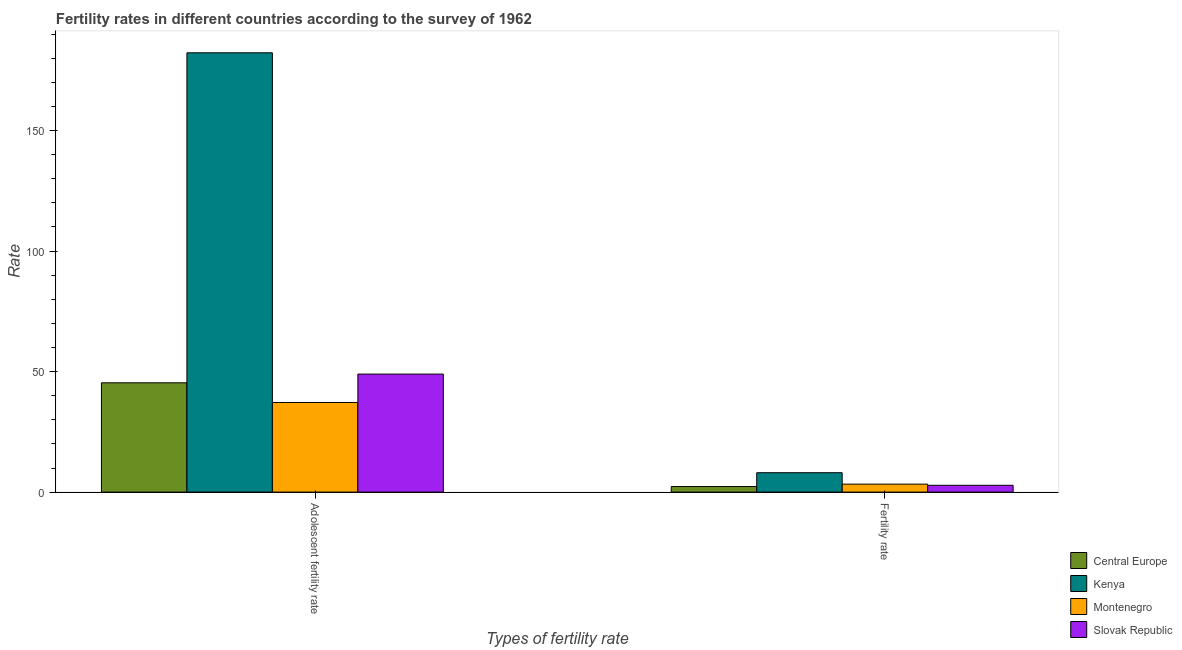Are the number of bars per tick equal to the number of legend labels?
Provide a succinct answer. Yes. How many bars are there on the 2nd tick from the left?
Provide a succinct answer. 4. How many bars are there on the 1st tick from the right?
Your answer should be very brief. 4. What is the label of the 2nd group of bars from the left?
Give a very brief answer. Fertility rate. What is the fertility rate in Slovak Republic?
Keep it short and to the point. 2.83. Across all countries, what is the maximum adolescent fertility rate?
Provide a succinct answer. 182.27. Across all countries, what is the minimum adolescent fertility rate?
Keep it short and to the point. 37.17. In which country was the adolescent fertility rate maximum?
Ensure brevity in your answer.  Kenya. In which country was the fertility rate minimum?
Your answer should be compact. Central Europe. What is the total fertility rate in the graph?
Provide a succinct answer. 16.49. What is the difference between the fertility rate in Kenya and that in Slovak Republic?
Your answer should be compact. 5.21. What is the difference between the adolescent fertility rate in Central Europe and the fertility rate in Montenegro?
Provide a succinct answer. 42.04. What is the average fertility rate per country?
Give a very brief answer. 4.12. What is the difference between the adolescent fertility rate and fertility rate in Central Europe?
Offer a terse response. 43.03. What is the ratio of the fertility rate in Central Europe to that in Slovak Republic?
Ensure brevity in your answer.  0.82. Is the fertility rate in Slovak Republic less than that in Montenegro?
Your answer should be very brief. Yes. What does the 2nd bar from the left in Adolescent fertility rate represents?
Provide a succinct answer. Kenya. What does the 2nd bar from the right in Adolescent fertility rate represents?
Offer a terse response. Montenegro. How many countries are there in the graph?
Offer a very short reply. 4. Does the graph contain any zero values?
Keep it short and to the point. No. How many legend labels are there?
Your response must be concise. 4. How are the legend labels stacked?
Provide a succinct answer. Vertical. What is the title of the graph?
Your answer should be compact. Fertility rates in different countries according to the survey of 1962. What is the label or title of the X-axis?
Give a very brief answer. Types of fertility rate. What is the label or title of the Y-axis?
Provide a succinct answer. Rate. What is the Rate in Central Europe in Adolescent fertility rate?
Offer a terse response. 45.35. What is the Rate of Kenya in Adolescent fertility rate?
Make the answer very short. 182.27. What is the Rate in Montenegro in Adolescent fertility rate?
Offer a very short reply. 37.17. What is the Rate in Slovak Republic in Adolescent fertility rate?
Give a very brief answer. 48.96. What is the Rate of Central Europe in Fertility rate?
Give a very brief answer. 2.31. What is the Rate of Kenya in Fertility rate?
Give a very brief answer. 8.04. What is the Rate of Montenegro in Fertility rate?
Your response must be concise. 3.31. What is the Rate of Slovak Republic in Fertility rate?
Provide a succinct answer. 2.83. Across all Types of fertility rate, what is the maximum Rate in Central Europe?
Make the answer very short. 45.35. Across all Types of fertility rate, what is the maximum Rate of Kenya?
Make the answer very short. 182.27. Across all Types of fertility rate, what is the maximum Rate in Montenegro?
Offer a very short reply. 37.17. Across all Types of fertility rate, what is the maximum Rate of Slovak Republic?
Give a very brief answer. 48.96. Across all Types of fertility rate, what is the minimum Rate of Central Europe?
Your response must be concise. 2.31. Across all Types of fertility rate, what is the minimum Rate of Kenya?
Provide a short and direct response. 8.04. Across all Types of fertility rate, what is the minimum Rate of Montenegro?
Ensure brevity in your answer.  3.31. Across all Types of fertility rate, what is the minimum Rate in Slovak Republic?
Make the answer very short. 2.83. What is the total Rate in Central Europe in the graph?
Keep it short and to the point. 47.66. What is the total Rate in Kenya in the graph?
Provide a succinct answer. 190.31. What is the total Rate in Montenegro in the graph?
Ensure brevity in your answer.  40.48. What is the total Rate in Slovak Republic in the graph?
Ensure brevity in your answer.  51.79. What is the difference between the Rate in Central Europe in Adolescent fertility rate and that in Fertility rate?
Offer a very short reply. 43.03. What is the difference between the Rate in Kenya in Adolescent fertility rate and that in Fertility rate?
Keep it short and to the point. 174.23. What is the difference between the Rate of Montenegro in Adolescent fertility rate and that in Fertility rate?
Give a very brief answer. 33.87. What is the difference between the Rate of Slovak Republic in Adolescent fertility rate and that in Fertility rate?
Provide a succinct answer. 46.13. What is the difference between the Rate of Central Europe in Adolescent fertility rate and the Rate of Kenya in Fertility rate?
Ensure brevity in your answer.  37.3. What is the difference between the Rate of Central Europe in Adolescent fertility rate and the Rate of Montenegro in Fertility rate?
Provide a short and direct response. 42.04. What is the difference between the Rate in Central Europe in Adolescent fertility rate and the Rate in Slovak Republic in Fertility rate?
Your response must be concise. 42.52. What is the difference between the Rate in Kenya in Adolescent fertility rate and the Rate in Montenegro in Fertility rate?
Offer a very short reply. 178.96. What is the difference between the Rate of Kenya in Adolescent fertility rate and the Rate of Slovak Republic in Fertility rate?
Offer a very short reply. 179.44. What is the difference between the Rate in Montenegro in Adolescent fertility rate and the Rate in Slovak Republic in Fertility rate?
Your answer should be very brief. 34.34. What is the average Rate in Central Europe per Types of fertility rate?
Offer a terse response. 23.83. What is the average Rate of Kenya per Types of fertility rate?
Your response must be concise. 95.16. What is the average Rate of Montenegro per Types of fertility rate?
Provide a succinct answer. 20.24. What is the average Rate in Slovak Republic per Types of fertility rate?
Offer a very short reply. 25.9. What is the difference between the Rate of Central Europe and Rate of Kenya in Adolescent fertility rate?
Offer a very short reply. -136.92. What is the difference between the Rate of Central Europe and Rate of Montenegro in Adolescent fertility rate?
Your answer should be compact. 8.17. What is the difference between the Rate in Central Europe and Rate in Slovak Republic in Adolescent fertility rate?
Your answer should be compact. -3.62. What is the difference between the Rate of Kenya and Rate of Montenegro in Adolescent fertility rate?
Provide a short and direct response. 145.09. What is the difference between the Rate in Kenya and Rate in Slovak Republic in Adolescent fertility rate?
Ensure brevity in your answer.  133.31. What is the difference between the Rate of Montenegro and Rate of Slovak Republic in Adolescent fertility rate?
Keep it short and to the point. -11.79. What is the difference between the Rate of Central Europe and Rate of Kenya in Fertility rate?
Make the answer very short. -5.73. What is the difference between the Rate in Central Europe and Rate in Montenegro in Fertility rate?
Your answer should be compact. -1. What is the difference between the Rate in Central Europe and Rate in Slovak Republic in Fertility rate?
Provide a succinct answer. -0.52. What is the difference between the Rate of Kenya and Rate of Montenegro in Fertility rate?
Provide a short and direct response. 4.73. What is the difference between the Rate of Kenya and Rate of Slovak Republic in Fertility rate?
Your answer should be very brief. 5.21. What is the difference between the Rate of Montenegro and Rate of Slovak Republic in Fertility rate?
Offer a terse response. 0.48. What is the ratio of the Rate of Central Europe in Adolescent fertility rate to that in Fertility rate?
Give a very brief answer. 19.62. What is the ratio of the Rate in Kenya in Adolescent fertility rate to that in Fertility rate?
Offer a terse response. 22.66. What is the ratio of the Rate in Montenegro in Adolescent fertility rate to that in Fertility rate?
Ensure brevity in your answer.  11.24. What is the ratio of the Rate in Slovak Republic in Adolescent fertility rate to that in Fertility rate?
Your answer should be compact. 17.3. What is the difference between the highest and the second highest Rate in Central Europe?
Keep it short and to the point. 43.03. What is the difference between the highest and the second highest Rate in Kenya?
Make the answer very short. 174.23. What is the difference between the highest and the second highest Rate of Montenegro?
Ensure brevity in your answer.  33.87. What is the difference between the highest and the second highest Rate of Slovak Republic?
Your response must be concise. 46.13. What is the difference between the highest and the lowest Rate of Central Europe?
Offer a very short reply. 43.03. What is the difference between the highest and the lowest Rate in Kenya?
Offer a very short reply. 174.23. What is the difference between the highest and the lowest Rate in Montenegro?
Give a very brief answer. 33.87. What is the difference between the highest and the lowest Rate of Slovak Republic?
Your response must be concise. 46.13. 